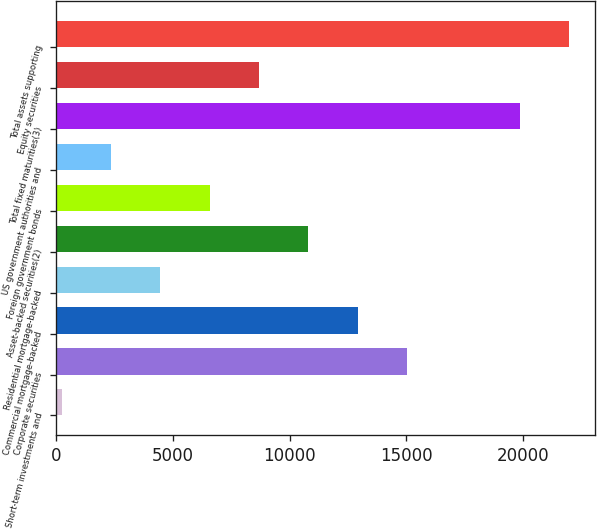Convert chart. <chart><loc_0><loc_0><loc_500><loc_500><bar_chart><fcel>Short-term investments and<fcel>Corporate securities<fcel>Commercial mortgage-backed<fcel>Residential mortgage-backed<fcel>Asset-backed securities(2)<fcel>Foreign government bonds<fcel>US government authorities and<fcel>Total fixed maturities(3)<fcel>Equity securities<fcel>Total assets supporting<nl><fcel>245<fcel>15028.3<fcel>12916.4<fcel>4468.8<fcel>10804.5<fcel>6580.7<fcel>2356.9<fcel>19841<fcel>8692.6<fcel>21952.9<nl></chart> 